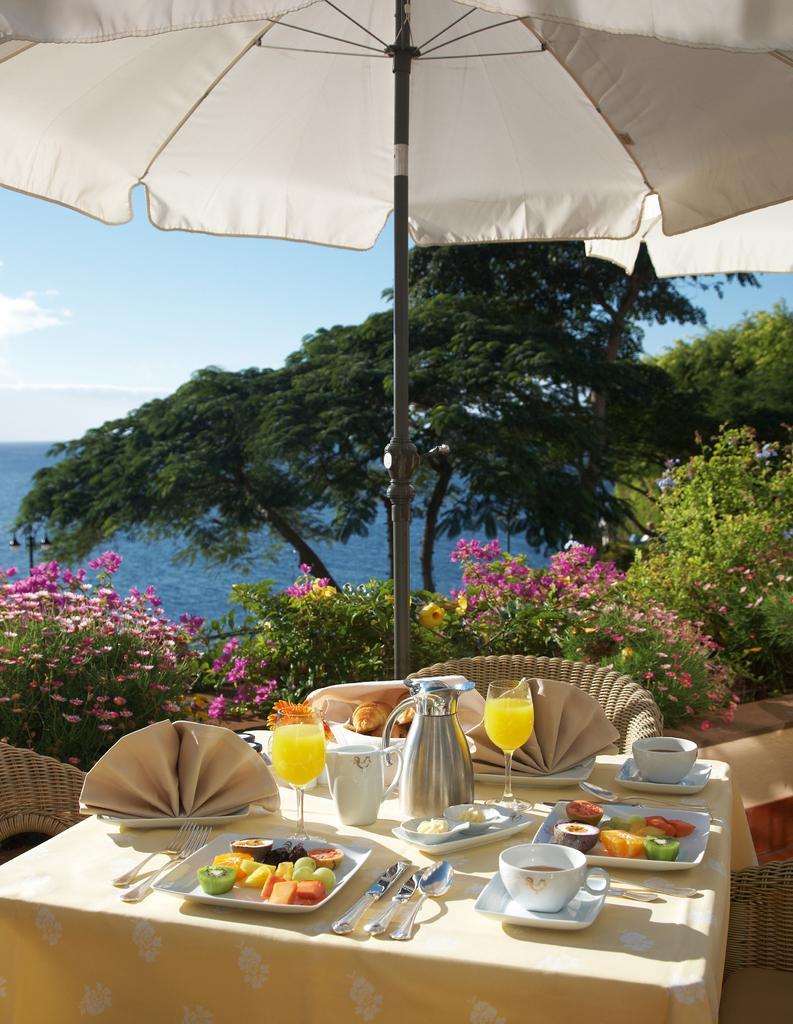Describe this image in one or two sentences. In this image in the middle, there is a table on that there are cups, plates, fruits, tissues, jug, glasses, drink, some other items, around the table there are chairs. At the top there is an umbrella. In the middle there are trees, plants, flowers, hills, sky and clouds. 